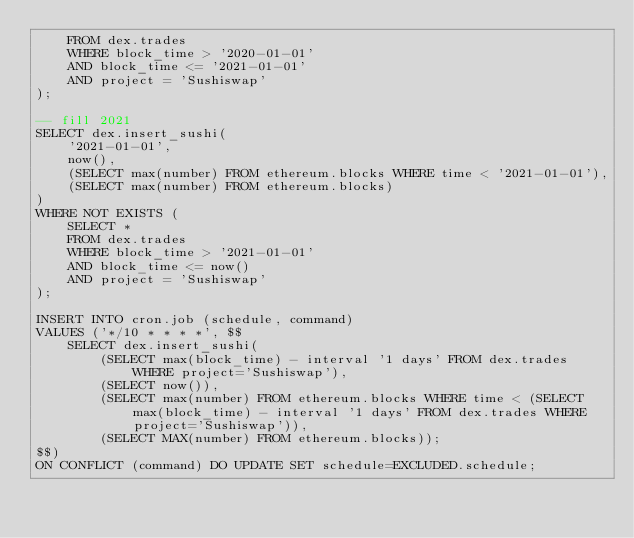Convert code to text. <code><loc_0><loc_0><loc_500><loc_500><_SQL_>    FROM dex.trades
    WHERE block_time > '2020-01-01'
    AND block_time <= '2021-01-01'
    AND project = 'Sushiswap'
);

-- fill 2021
SELECT dex.insert_sushi(
    '2021-01-01',
    now(),
    (SELECT max(number) FROM ethereum.blocks WHERE time < '2021-01-01'),
    (SELECT max(number) FROM ethereum.blocks)
)
WHERE NOT EXISTS (
    SELECT *
    FROM dex.trades
    WHERE block_time > '2021-01-01'
    AND block_time <= now()
    AND project = 'Sushiswap'
);

INSERT INTO cron.job (schedule, command)
VALUES ('*/10 * * * *', $$
    SELECT dex.insert_sushi(
        (SELECT max(block_time) - interval '1 days' FROM dex.trades WHERE project='Sushiswap'),
        (SELECT now()),
        (SELECT max(number) FROM ethereum.blocks WHERE time < (SELECT max(block_time) - interval '1 days' FROM dex.trades WHERE project='Sushiswap')),
        (SELECT MAX(number) FROM ethereum.blocks));
$$)
ON CONFLICT (command) DO UPDATE SET schedule=EXCLUDED.schedule;</code> 